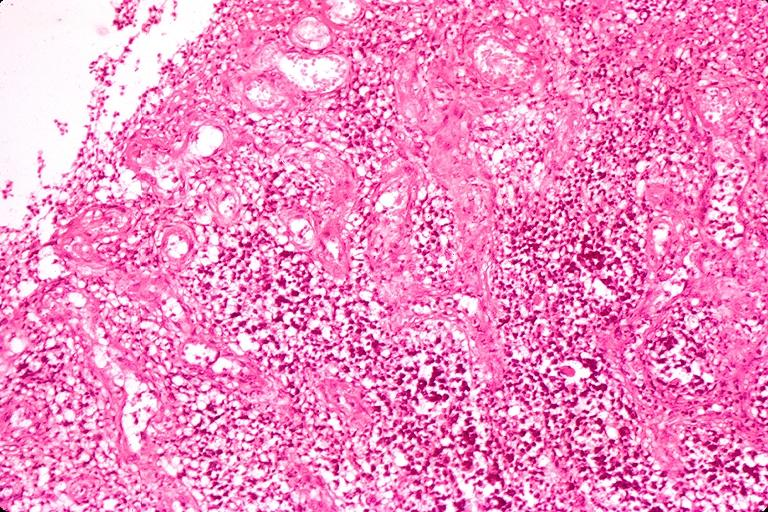does this image show chronic hyperplasitic pulpitis?
Answer the question using a single word or phrase. Yes 